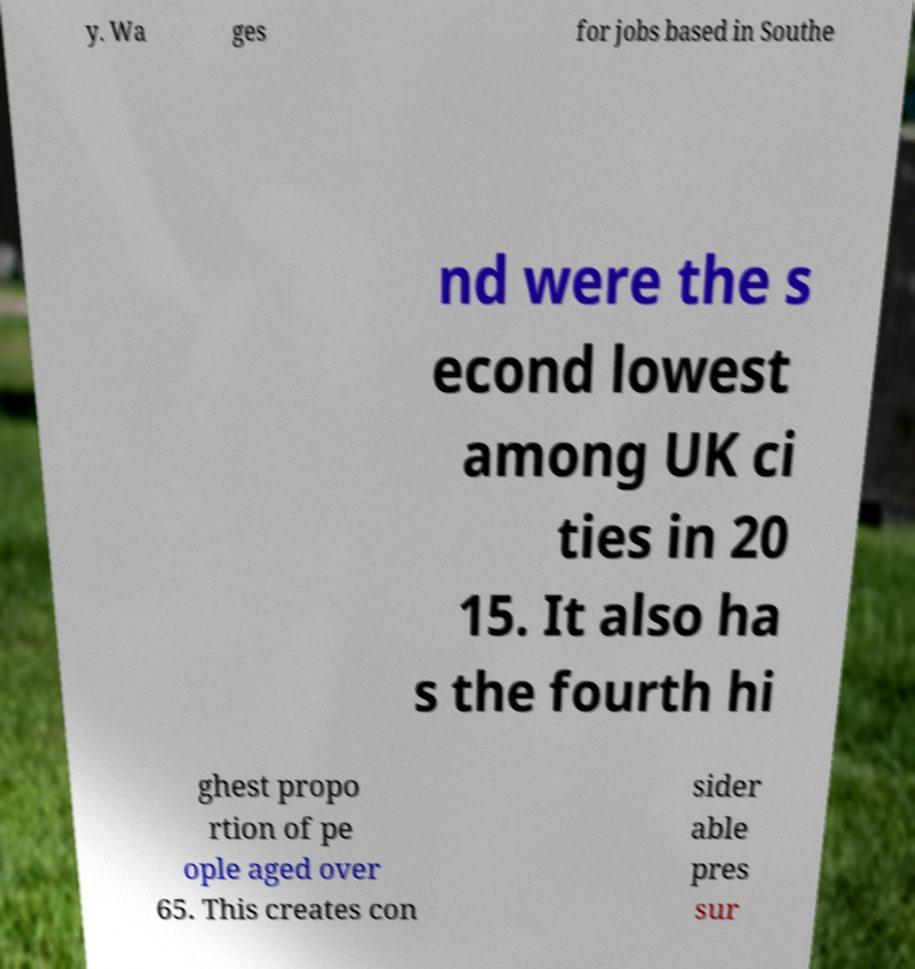Could you extract and type out the text from this image? y. Wa ges for jobs based in Southe nd were the s econd lowest among UK ci ties in 20 15. It also ha s the fourth hi ghest propo rtion of pe ople aged over 65. This creates con sider able pres sur 